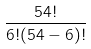<formula> <loc_0><loc_0><loc_500><loc_500>\frac { 5 4 ! } { 6 ! ( 5 4 - 6 ) ! }</formula> 